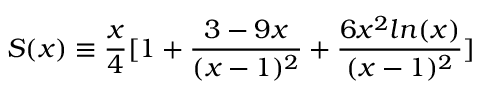<formula> <loc_0><loc_0><loc_500><loc_500>S ( x ) \equiv \frac { x } { 4 } [ 1 + \frac { 3 - 9 x } { ( x - 1 ) ^ { 2 } } + \frac { 6 x ^ { 2 } \ln ( x ) } { ( x - 1 ) ^ { 2 } } ]</formula> 